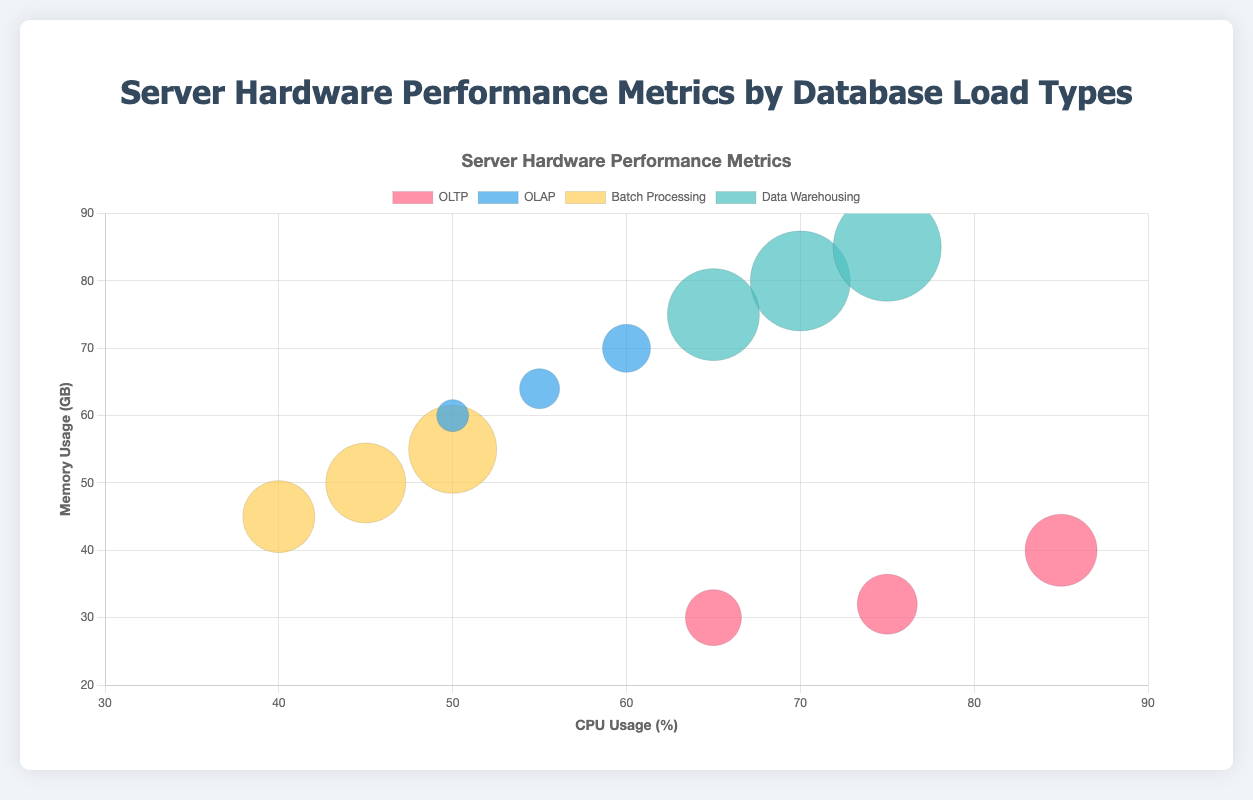What is the title of the figure? The title of the figure is located at the top and is labeled within the chart options. It reads "Server Hardware Performance Metrics by Database Load Types".
Answer: Server Hardware Performance Metrics by Database Load Types Which database load type has the highest CPU usage? To identify the highest CPU usage, look at the x-axis representing CPU Usage (%). The data point with the highest x-value belongs to the "OLTP" load type.
Answer: OLTP How many data points are there in total? Count the number of data points (bubbles) in the chart. There are four distinct groups (OLTP, OLAP, Batch Processing, Data Warehousing), each with 3 data points. Hence, the total is 4 * 3.
Answer: 12 Which database load type uses the most memory on average? Calculate the average memory usage for each load type by adding up the y-values of memory usage and dividing by the number of data points for each type. OLTP: (32+40+30)/3 = 34; OLAP: (64+70+60)/3 = 64.67; Batch Processing: (50+55+45)/3 = 50; Data Warehousing: (80+85+75)/3 = 80. Average memory usage is highest for "Data Warehousing".
Answer: Data Warehousing Between "OLTP" and "Batch Processing", which has a higher average disk usage? Calculate average disk usage (r-value * 5): OLTP: (150+180+140)/3 = 156.67; Batch Processing: (200+220+180)/3 = 200. OLTP has a lower average than Batch Processing.
Answer: Batch Processing Which database load type has the most balanced distribution of CPU and Memory usage? To find the most balanced distribution, look for load types with CPU and Memory usage data close together across all its points. Scan the x and y axes values per load type. "Data Warehousing" having CPU: 70, 75, 65 and Memory: 80, 85, 75 is the most balanced.
Answer: Data Warehousing What is the disk usage for the data point with the highest memory usage? Identify the data point with the highest y-value (memory), which is 85 GB for "Data Warehousing". Check the corresponding disk usage value, which is indicated as 270 GB/s.
Answer: 270 GB/s Which database load type shows the most consistent CPU usage? The most consistent CPU usage means the values are closest together. Calculate the range of CPU usage for each load type: OLTP (85-65=20), OLAP (60-50=10), Batch Processing (50-40=10), Data Warehousing (75-65=10). The smallest range is 10, so "OLAP," "Batch Processing," and "Data Warehousing" show the most consistent usage.
Answer: OLAP, Batch Processing, Data Warehousing How do the memory usage values for "OLTP" compare to those for "OLAP"? "OLTP" data points for memory usage are 32, 40, 30 GB. "OLAP" data points are 64, 70, 60 GB. Observing the y-axis values indicates higher memory usage for "OLAP".
Answer: OLAP has higher memory usage 